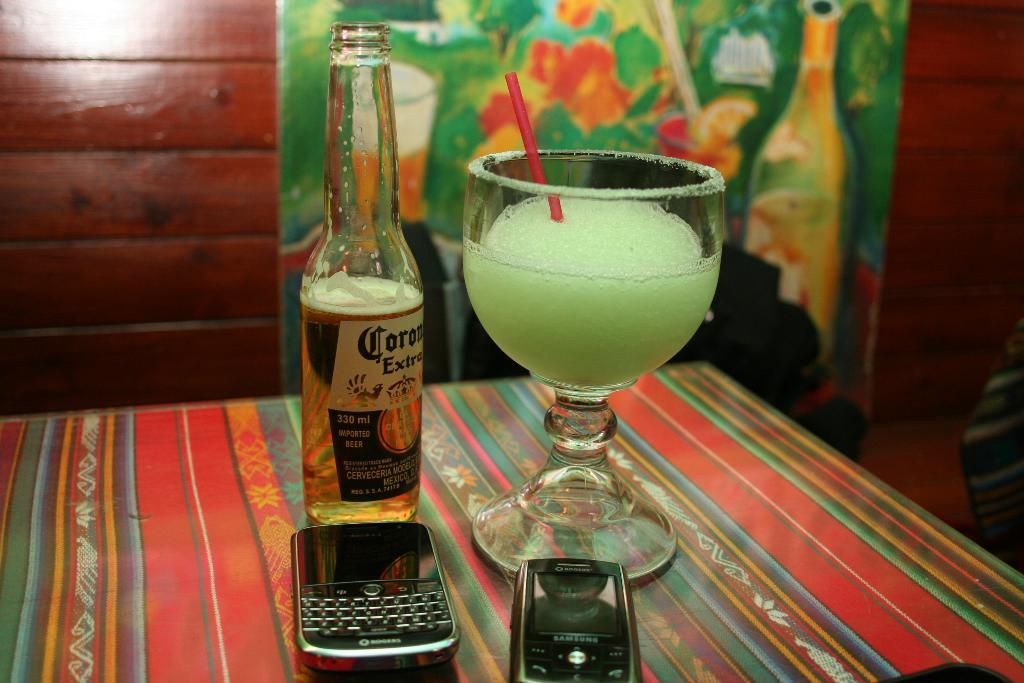<image>
Summarize the visual content of the image. A bottle of Corona beer next to a glass of pale green liquid. 